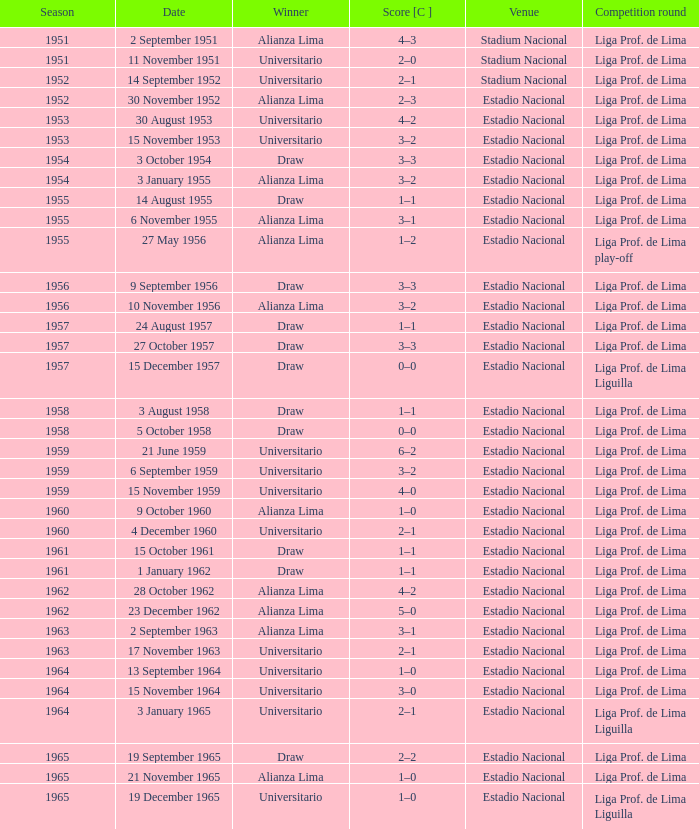Who was the winner on 15 December 1957? Draw. 